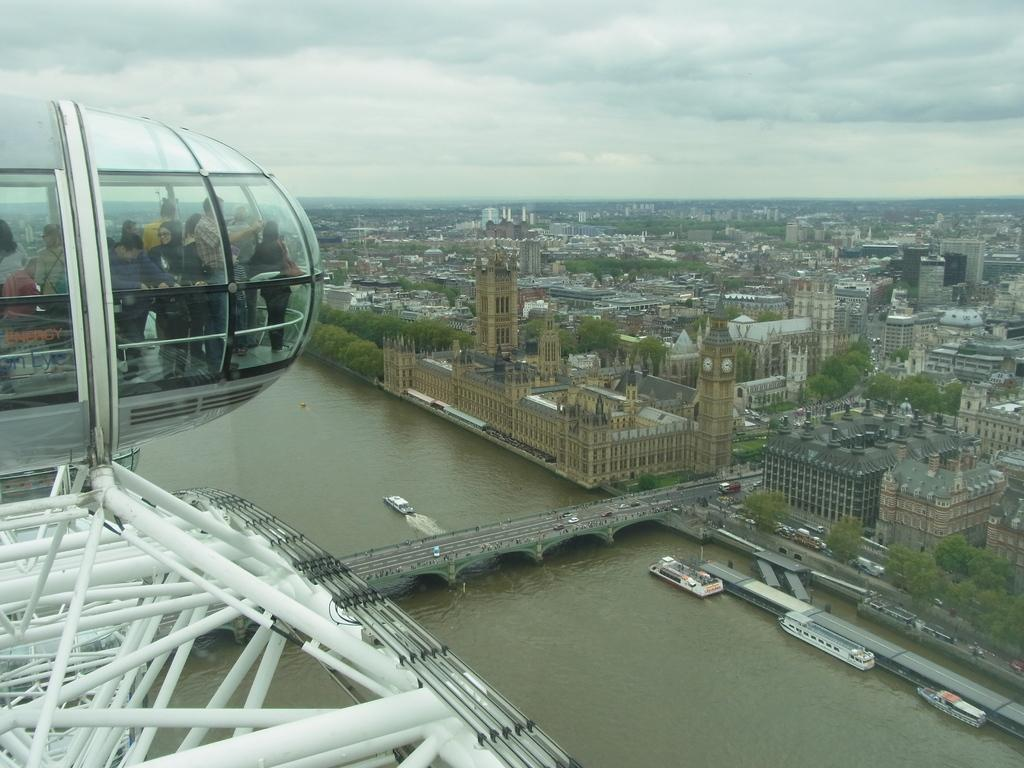What is the main subject of the image? The image is an aerial view of the houses of parliament in London. Can you identify any specific structures in the image? Yes, there is a bridge visible in the image. How many buildings can be seen in the image? There are many buildings in the image. What is the condition of the sky in the image? The sky is full of clouds. What type of mass can be seen coiled around the lamp in the image? There is no mass or lamp present in the image; it is an aerial view of the houses of parliament in London with a focus on the buildings and the bridge. 